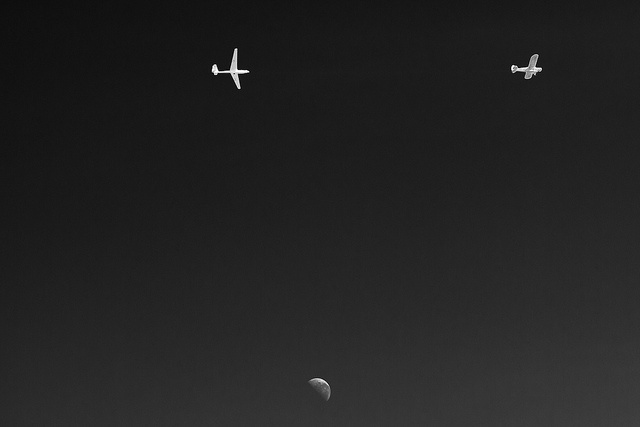Describe the objects in this image and their specific colors. I can see airplane in black, lightgray, darkgray, and gray tones and airplane in black, darkgray, lightgray, and gray tones in this image. 